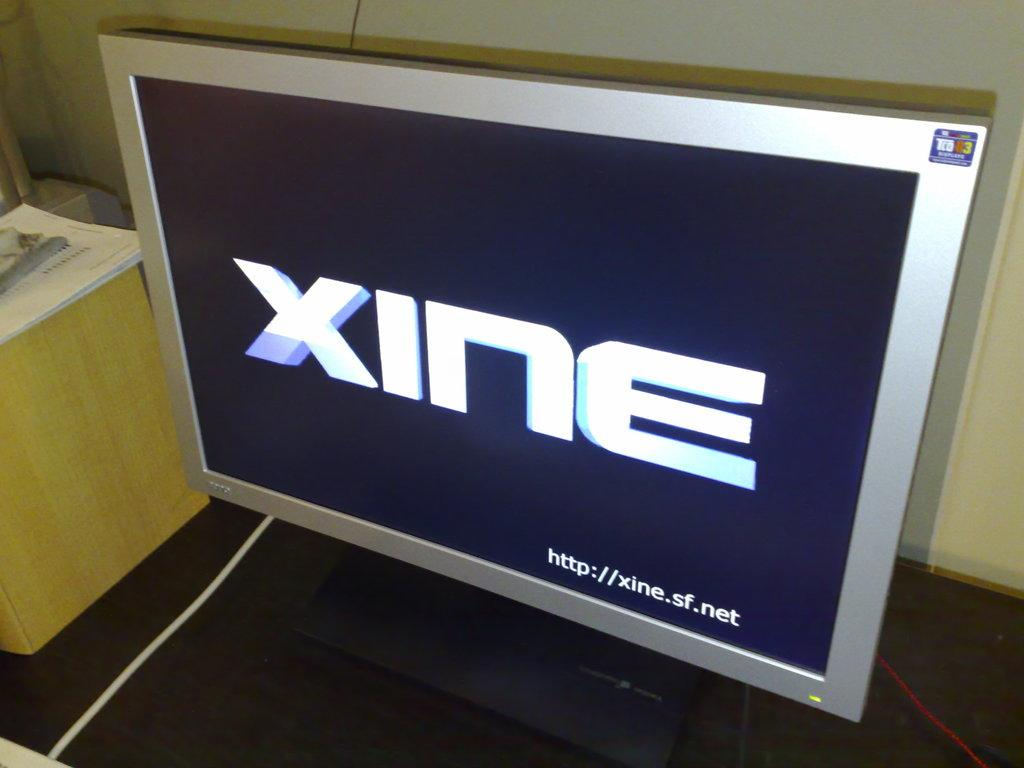Provide a one-sentence caption for the provided image. A silver-framed TV screen displays the word xine. 